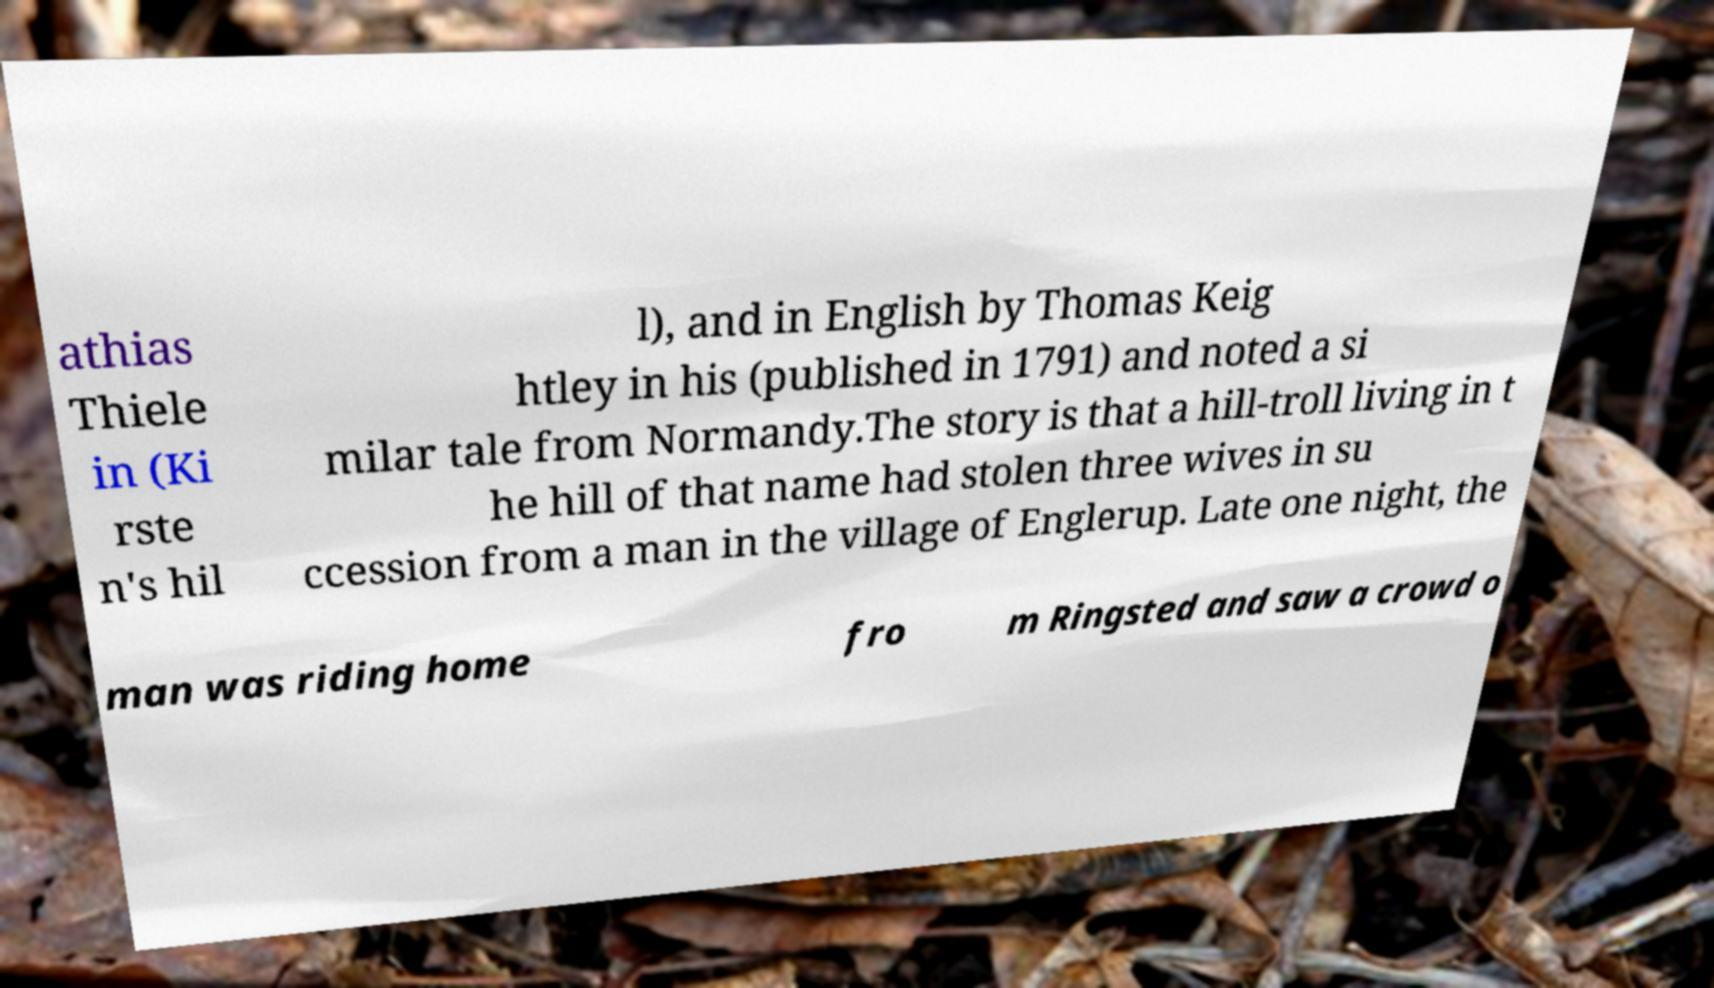I need the written content from this picture converted into text. Can you do that? athias Thiele in (Ki rste n's hil l), and in English by Thomas Keig htley in his (published in 1791) and noted a si milar tale from Normandy.The story is that a hill-troll living in t he hill of that name had stolen three wives in su ccession from a man in the village of Englerup. Late one night, the man was riding home fro m Ringsted and saw a crowd o 